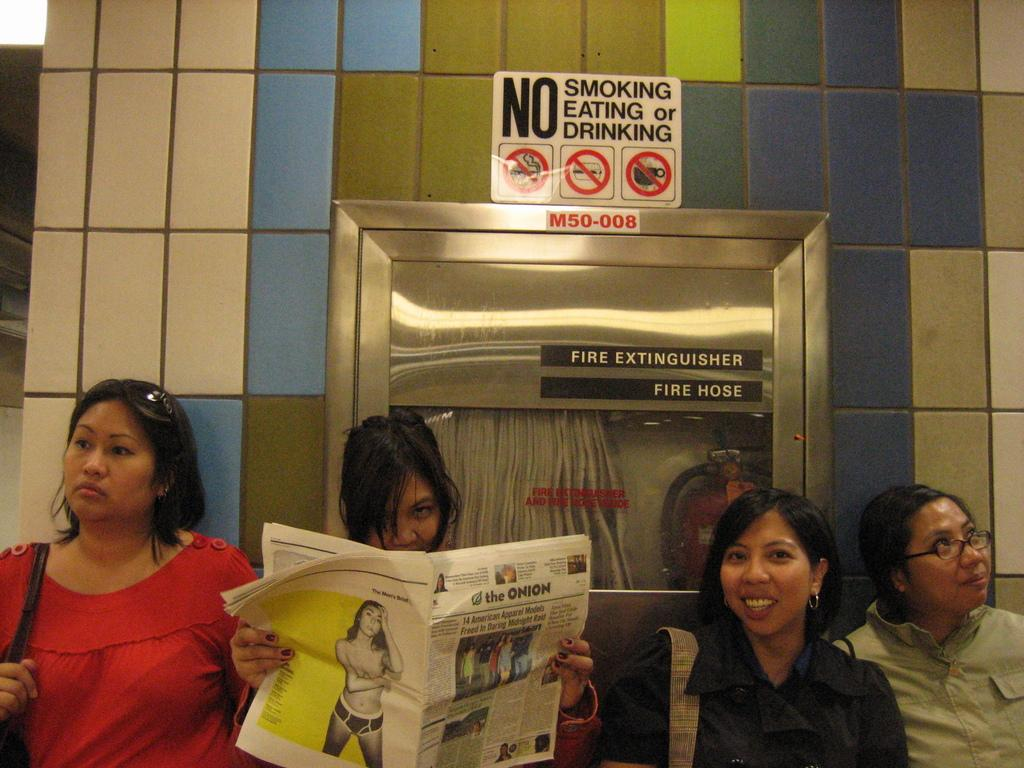How many people are in the image? There are four persons in the image. What is one person doing in the image? One person is holding a newspaper. What can be seen in the image besides the people? There is a signboard and a fire extinguisher attached to the wall in the image. What type of alley can be seen behind the persons in the image? There is no alley visible in the image; it only shows four persons, a signboard, and a fire extinguisher. 